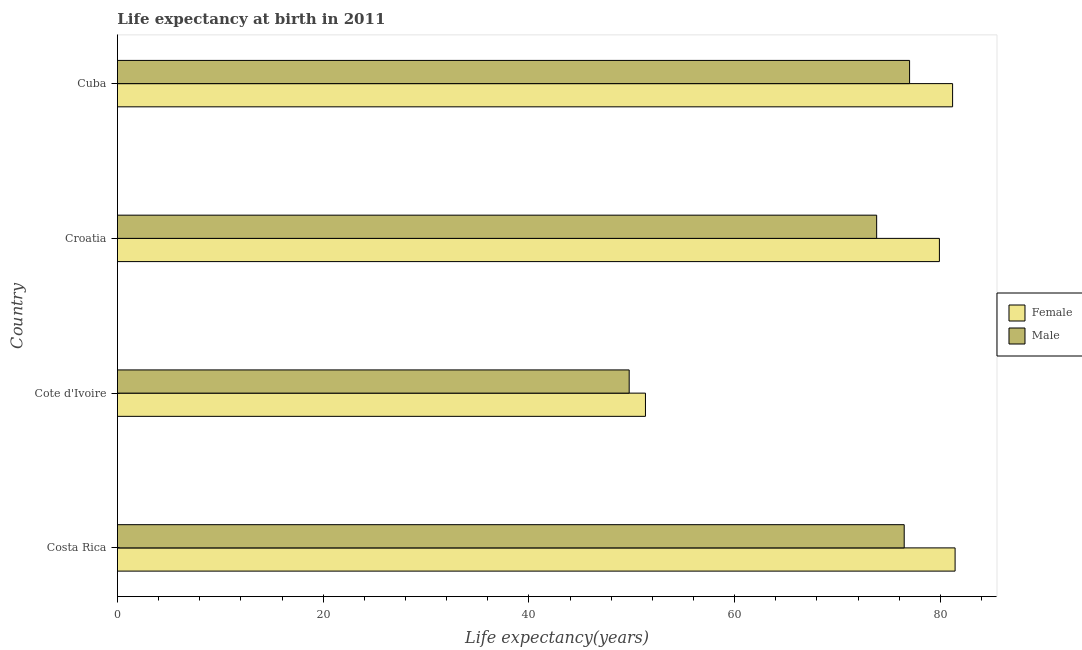How many different coloured bars are there?
Offer a terse response. 2. Are the number of bars per tick equal to the number of legend labels?
Keep it short and to the point. Yes. Are the number of bars on each tick of the Y-axis equal?
Keep it short and to the point. Yes. How many bars are there on the 2nd tick from the bottom?
Your response must be concise. 2. What is the life expectancy(female) in Cuba?
Ensure brevity in your answer.  81.18. Across all countries, what is the maximum life expectancy(female)?
Provide a short and direct response. 81.42. Across all countries, what is the minimum life expectancy(male)?
Your answer should be very brief. 49.75. In which country was the life expectancy(female) maximum?
Your answer should be very brief. Costa Rica. In which country was the life expectancy(female) minimum?
Your answer should be compact. Cote d'Ivoire. What is the total life expectancy(male) in the graph?
Ensure brevity in your answer.  277.02. What is the difference between the life expectancy(female) in Cote d'Ivoire and that in Croatia?
Offer a very short reply. -28.57. What is the difference between the life expectancy(male) in Croatia and the life expectancy(female) in Cote d'Ivoire?
Make the answer very short. 22.47. What is the average life expectancy(male) per country?
Offer a very short reply. 69.26. What is the difference between the life expectancy(female) and life expectancy(male) in Cuba?
Keep it short and to the point. 4.18. What is the ratio of the life expectancy(female) in Costa Rica to that in Cote d'Ivoire?
Your response must be concise. 1.59. Is the difference between the life expectancy(male) in Costa Rica and Cuba greater than the difference between the life expectancy(female) in Costa Rica and Cuba?
Provide a short and direct response. No. What is the difference between the highest and the second highest life expectancy(female)?
Offer a very short reply. 0.24. What is the difference between the highest and the lowest life expectancy(male)?
Offer a very short reply. 27.25. What does the 1st bar from the top in Costa Rica represents?
Offer a terse response. Male. What does the 2nd bar from the bottom in Cote d'Ivoire represents?
Provide a succinct answer. Male. How many countries are there in the graph?
Your answer should be compact. 4. Where does the legend appear in the graph?
Offer a terse response. Center right. How many legend labels are there?
Ensure brevity in your answer.  2. How are the legend labels stacked?
Ensure brevity in your answer.  Vertical. What is the title of the graph?
Make the answer very short. Life expectancy at birth in 2011. Does "Depositors" appear as one of the legend labels in the graph?
Make the answer very short. No. What is the label or title of the X-axis?
Make the answer very short. Life expectancy(years). What is the label or title of the Y-axis?
Offer a very short reply. Country. What is the Life expectancy(years) in Female in Costa Rica?
Provide a succinct answer. 81.42. What is the Life expectancy(years) of Male in Costa Rica?
Make the answer very short. 76.48. What is the Life expectancy(years) in Female in Cote d'Ivoire?
Give a very brief answer. 51.33. What is the Life expectancy(years) of Male in Cote d'Ivoire?
Offer a very short reply. 49.75. What is the Life expectancy(years) in Female in Croatia?
Offer a very short reply. 79.9. What is the Life expectancy(years) in Male in Croatia?
Offer a terse response. 73.8. What is the Life expectancy(years) of Female in Cuba?
Ensure brevity in your answer.  81.18. Across all countries, what is the maximum Life expectancy(years) in Female?
Give a very brief answer. 81.42. Across all countries, what is the maximum Life expectancy(years) of Male?
Keep it short and to the point. 77. Across all countries, what is the minimum Life expectancy(years) of Female?
Make the answer very short. 51.33. Across all countries, what is the minimum Life expectancy(years) of Male?
Offer a very short reply. 49.75. What is the total Life expectancy(years) in Female in the graph?
Your response must be concise. 293.83. What is the total Life expectancy(years) of Male in the graph?
Ensure brevity in your answer.  277.02. What is the difference between the Life expectancy(years) in Female in Costa Rica and that in Cote d'Ivoire?
Your response must be concise. 30.1. What is the difference between the Life expectancy(years) of Male in Costa Rica and that in Cote d'Ivoire?
Your answer should be very brief. 26.73. What is the difference between the Life expectancy(years) of Female in Costa Rica and that in Croatia?
Give a very brief answer. 1.52. What is the difference between the Life expectancy(years) of Male in Costa Rica and that in Croatia?
Ensure brevity in your answer.  2.68. What is the difference between the Life expectancy(years) of Female in Costa Rica and that in Cuba?
Your response must be concise. 0.24. What is the difference between the Life expectancy(years) in Male in Costa Rica and that in Cuba?
Make the answer very short. -0.52. What is the difference between the Life expectancy(years) in Female in Cote d'Ivoire and that in Croatia?
Make the answer very short. -28.57. What is the difference between the Life expectancy(years) in Male in Cote d'Ivoire and that in Croatia?
Provide a short and direct response. -24.05. What is the difference between the Life expectancy(years) of Female in Cote d'Ivoire and that in Cuba?
Provide a succinct answer. -29.85. What is the difference between the Life expectancy(years) in Male in Cote d'Ivoire and that in Cuba?
Keep it short and to the point. -27.25. What is the difference between the Life expectancy(years) of Female in Croatia and that in Cuba?
Provide a succinct answer. -1.28. What is the difference between the Life expectancy(years) of Female in Costa Rica and the Life expectancy(years) of Male in Cote d'Ivoire?
Ensure brevity in your answer.  31.68. What is the difference between the Life expectancy(years) in Female in Costa Rica and the Life expectancy(years) in Male in Croatia?
Make the answer very short. 7.62. What is the difference between the Life expectancy(years) in Female in Costa Rica and the Life expectancy(years) in Male in Cuba?
Keep it short and to the point. 4.42. What is the difference between the Life expectancy(years) of Female in Cote d'Ivoire and the Life expectancy(years) of Male in Croatia?
Your answer should be compact. -22.47. What is the difference between the Life expectancy(years) in Female in Cote d'Ivoire and the Life expectancy(years) in Male in Cuba?
Your answer should be compact. -25.67. What is the difference between the Life expectancy(years) of Female in Croatia and the Life expectancy(years) of Male in Cuba?
Make the answer very short. 2.9. What is the average Life expectancy(years) of Female per country?
Provide a succinct answer. 73.46. What is the average Life expectancy(years) of Male per country?
Ensure brevity in your answer.  69.26. What is the difference between the Life expectancy(years) of Female and Life expectancy(years) of Male in Costa Rica?
Make the answer very short. 4.95. What is the difference between the Life expectancy(years) of Female and Life expectancy(years) of Male in Cote d'Ivoire?
Keep it short and to the point. 1.58. What is the difference between the Life expectancy(years) of Female and Life expectancy(years) of Male in Cuba?
Your answer should be very brief. 4.18. What is the ratio of the Life expectancy(years) in Female in Costa Rica to that in Cote d'Ivoire?
Give a very brief answer. 1.59. What is the ratio of the Life expectancy(years) in Male in Costa Rica to that in Cote d'Ivoire?
Your answer should be compact. 1.54. What is the ratio of the Life expectancy(years) of Female in Costa Rica to that in Croatia?
Your answer should be very brief. 1.02. What is the ratio of the Life expectancy(years) of Male in Costa Rica to that in Croatia?
Your response must be concise. 1.04. What is the ratio of the Life expectancy(years) of Female in Costa Rica to that in Cuba?
Your answer should be compact. 1. What is the ratio of the Life expectancy(years) of Male in Costa Rica to that in Cuba?
Ensure brevity in your answer.  0.99. What is the ratio of the Life expectancy(years) of Female in Cote d'Ivoire to that in Croatia?
Provide a short and direct response. 0.64. What is the ratio of the Life expectancy(years) of Male in Cote d'Ivoire to that in Croatia?
Keep it short and to the point. 0.67. What is the ratio of the Life expectancy(years) of Female in Cote d'Ivoire to that in Cuba?
Keep it short and to the point. 0.63. What is the ratio of the Life expectancy(years) of Male in Cote d'Ivoire to that in Cuba?
Your answer should be compact. 0.65. What is the ratio of the Life expectancy(years) of Female in Croatia to that in Cuba?
Offer a very short reply. 0.98. What is the ratio of the Life expectancy(years) in Male in Croatia to that in Cuba?
Provide a short and direct response. 0.96. What is the difference between the highest and the second highest Life expectancy(years) of Female?
Give a very brief answer. 0.24. What is the difference between the highest and the second highest Life expectancy(years) of Male?
Provide a short and direct response. 0.52. What is the difference between the highest and the lowest Life expectancy(years) of Female?
Offer a very short reply. 30.1. What is the difference between the highest and the lowest Life expectancy(years) of Male?
Provide a succinct answer. 27.25. 